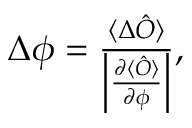<formula> <loc_0><loc_0><loc_500><loc_500>\begin{array} { r } { \Delta \phi = \frac { \langle \Delta \hat { O } \rangle } { \left | \frac { \partial \langle \hat { O } \rangle } { \partial \phi } \right | } , } \end{array}</formula> 